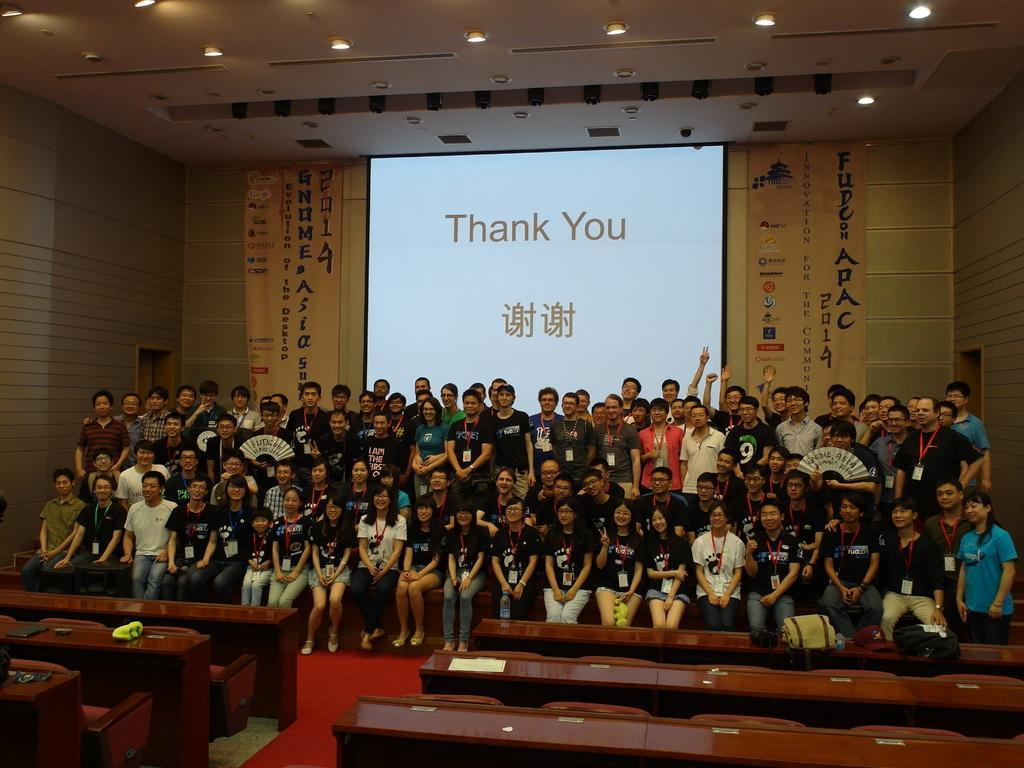How would you summarize this image in a sentence or two? In this picture we can see some people standing and some people sitting here, in the background there is a banner and a projector screen here, we can see desks here, there are some lights at the top of the picture. 